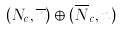Convert formula to latex. <formula><loc_0><loc_0><loc_500><loc_500>( { N _ { c } } , { \overline { n } } ) \oplus ( { \overline { N } _ { c } } , n )</formula> 